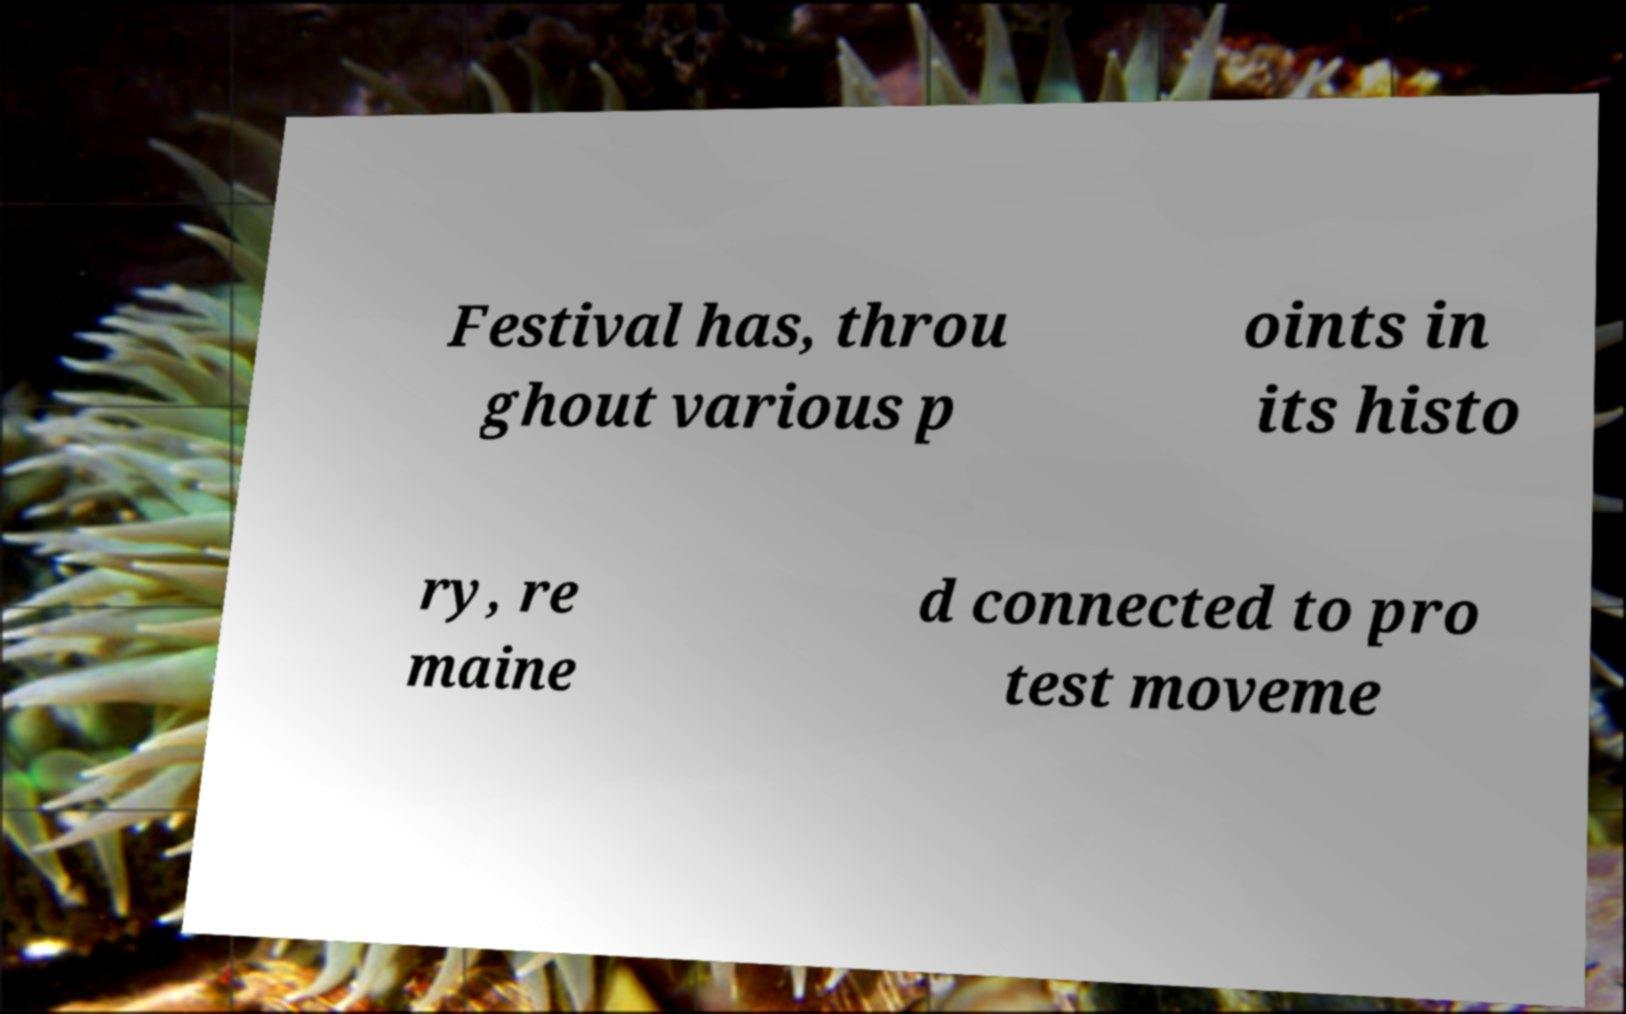Can you accurately transcribe the text from the provided image for me? Festival has, throu ghout various p oints in its histo ry, re maine d connected to pro test moveme 